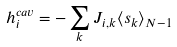Convert formula to latex. <formula><loc_0><loc_0><loc_500><loc_500>h _ { i } ^ { c a v } = - \sum _ { k } J _ { i , k } \langle s _ { k } \rangle _ { N - 1 }</formula> 